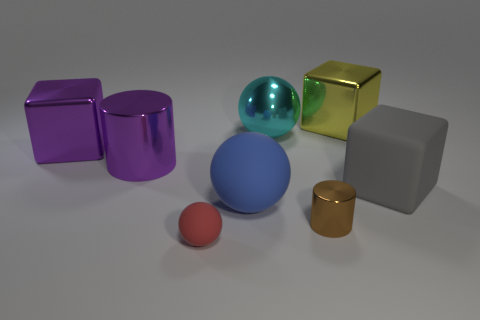Can you describe the lighting in this scene? The objects in the image are evenly lit by what appears to be a soft, diffused light source coming from above. Shadows are soft and there are slight reflections on the surfaces, indicating a well-lit environment that softens shadows and provides clarity to the objects' colors and shapes. 